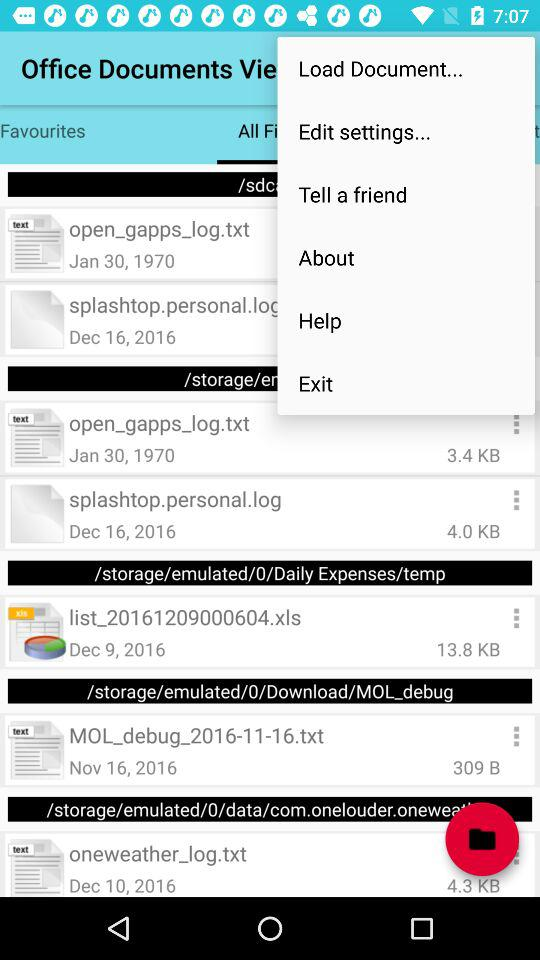What is the date of the file "oneweather_log.txt"? The date of the file "oneweather_log.txt" is December 10, 2016. 